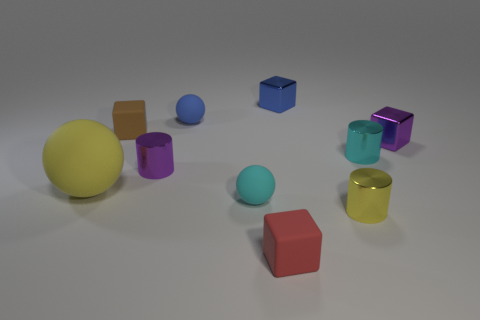Are there any other things that have the same size as the yellow sphere?
Your answer should be very brief. No. Does the tiny ball that is behind the yellow sphere have the same material as the tiny sphere in front of the brown rubber cube?
Your response must be concise. Yes. How many rubber blocks have the same size as the purple cylinder?
Give a very brief answer. 2. Are there fewer red blocks than tiny shiny cylinders?
Provide a succinct answer. Yes. The purple metal object behind the tiny metallic cylinder that is left of the blue block is what shape?
Offer a very short reply. Cube. What is the shape of the red matte thing that is the same size as the cyan cylinder?
Give a very brief answer. Cube. Is there a small blue thing that has the same shape as the small brown object?
Offer a very short reply. Yes. What material is the tiny brown thing?
Your answer should be compact. Rubber. Are there any tiny brown rubber blocks in front of the small yellow cylinder?
Provide a short and direct response. No. There is a small ball in front of the large yellow ball; how many tiny cyan matte balls are on the right side of it?
Offer a terse response. 0. 